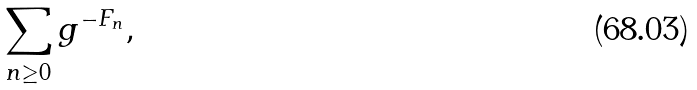Convert formula to latex. <formula><loc_0><loc_0><loc_500><loc_500>\sum _ { n \geq 0 } g ^ { - F _ { n } } ,</formula> 